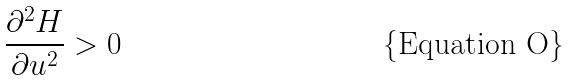<formula> <loc_0><loc_0><loc_500><loc_500>\frac { \partial ^ { 2 } H } { \partial u ^ { 2 } } > 0</formula> 